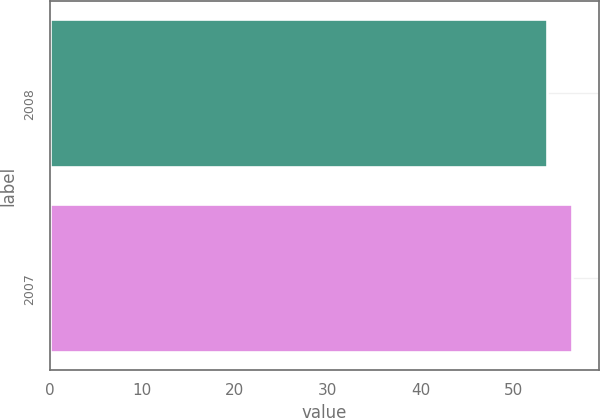Convert chart. <chart><loc_0><loc_0><loc_500><loc_500><bar_chart><fcel>2008<fcel>2007<nl><fcel>53.7<fcel>56.4<nl></chart> 